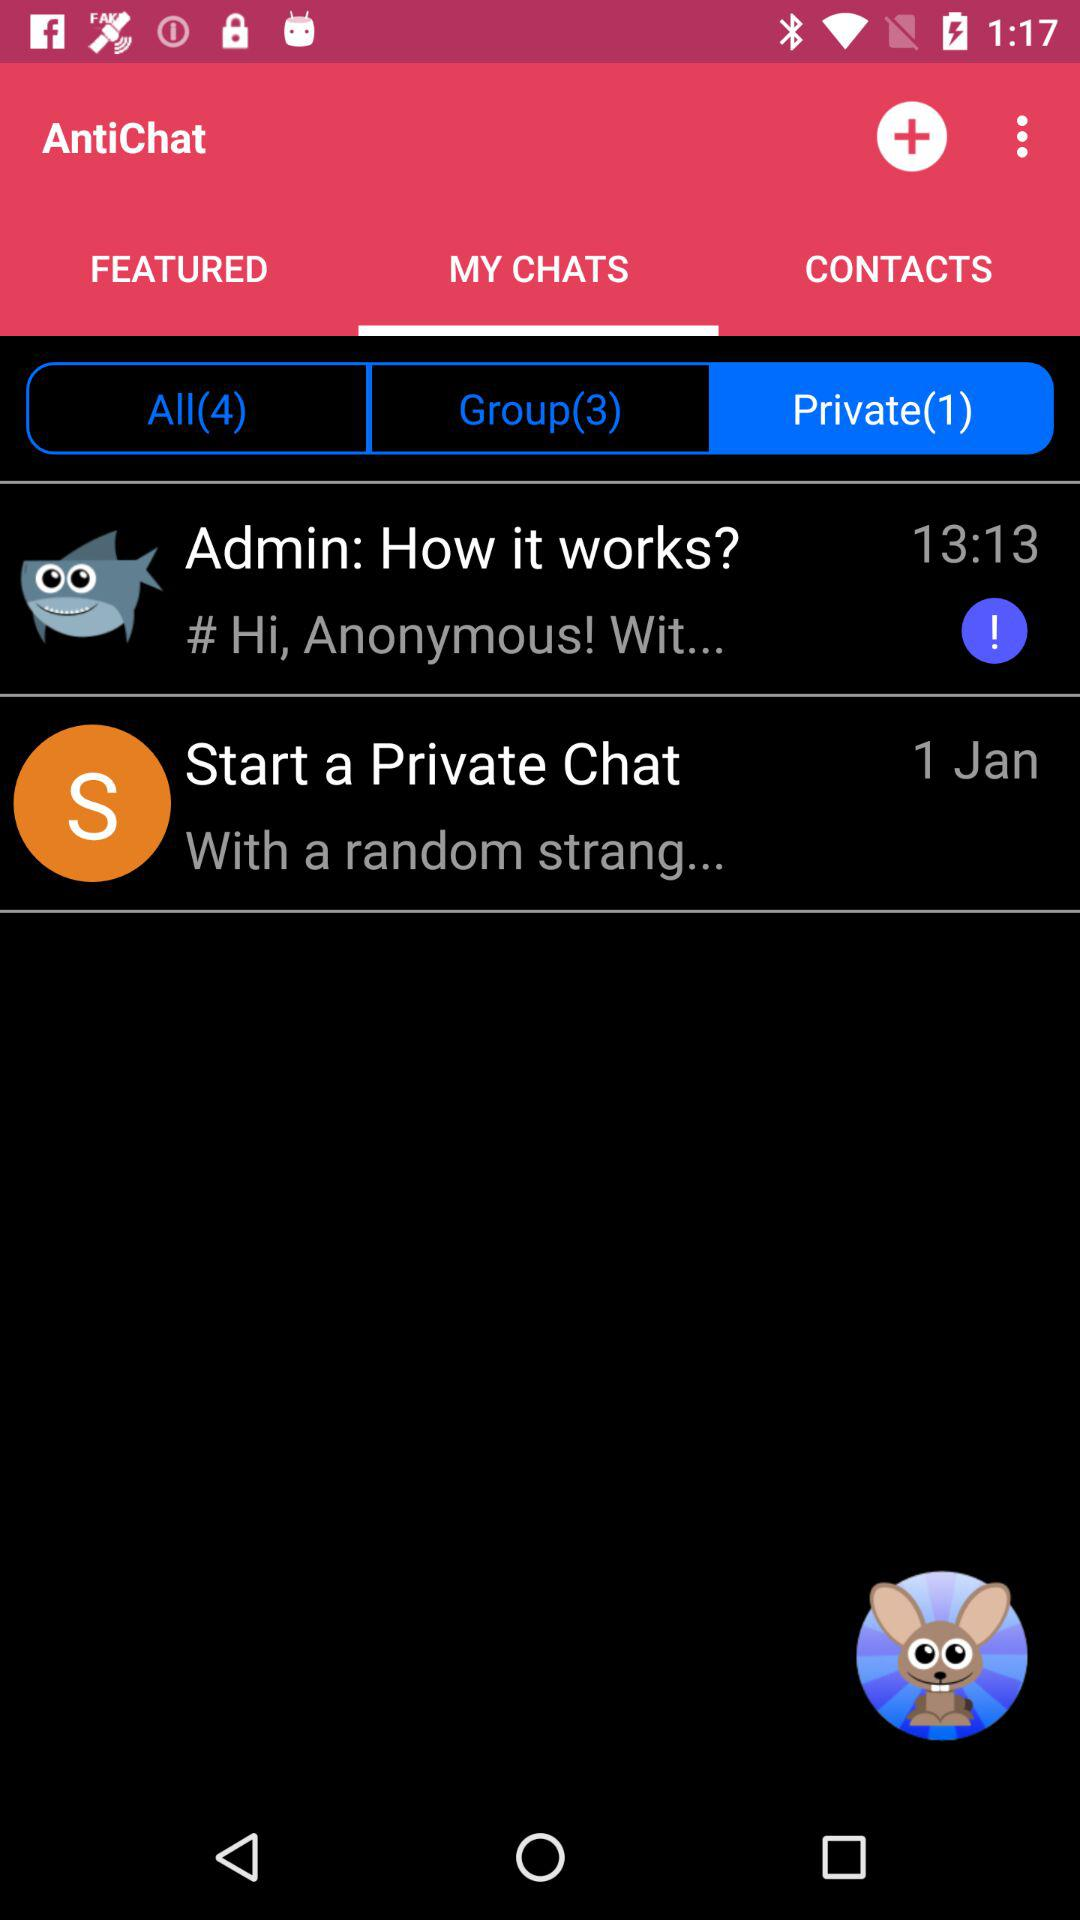Which tab is selected in AntiChat? The selected tab is "MY CHATS". 